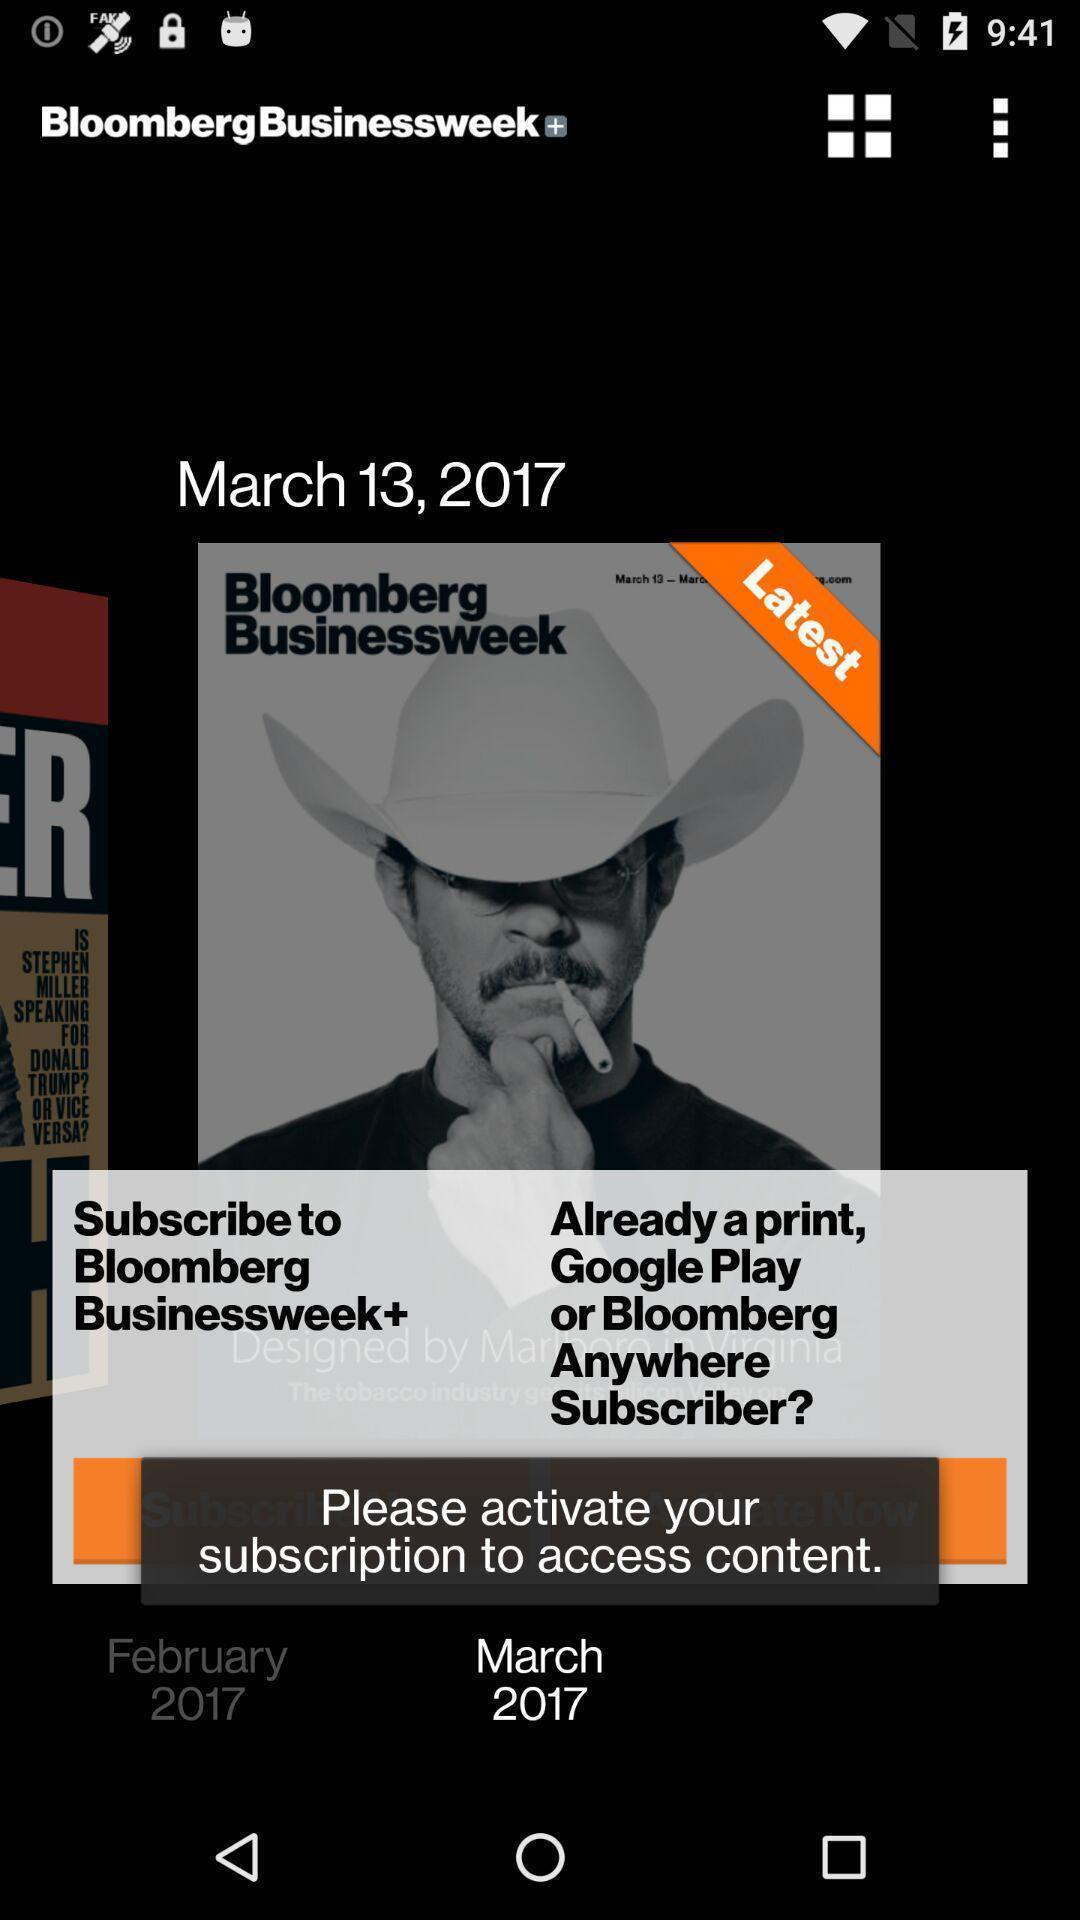Give me a narrative description of this picture. Pop up showing to activate subscription. 